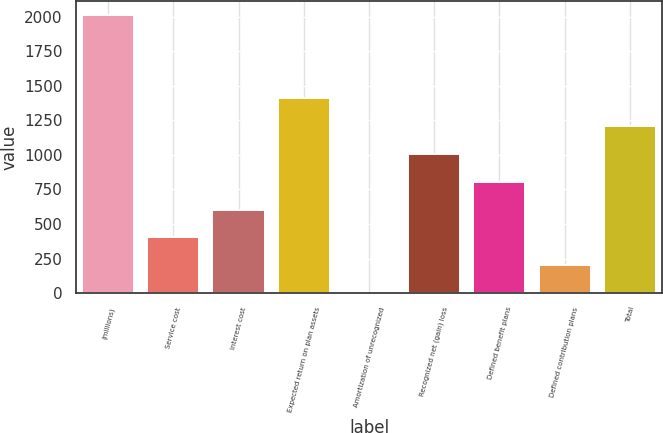Convert chart to OTSL. <chart><loc_0><loc_0><loc_500><loc_500><bar_chart><fcel>(millions)<fcel>Service cost<fcel>Interest cost<fcel>Expected return on plan assets<fcel>Amortization of unrecognized<fcel>Recognized net (gain) loss<fcel>Defined benefit plans<fcel>Defined contribution plans<fcel>Total<nl><fcel>2012<fcel>404<fcel>605<fcel>1409<fcel>2<fcel>1007<fcel>806<fcel>203<fcel>1208<nl></chart> 